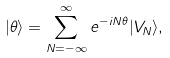Convert formula to latex. <formula><loc_0><loc_0><loc_500><loc_500>| \theta \rangle = \sum _ { N = - \infty } ^ { \infty } e ^ { - i N \theta } | V _ { N } \rangle ,</formula> 